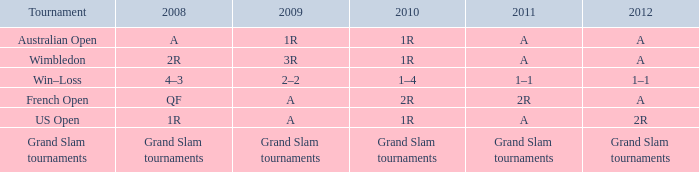Could you parse the entire table as a dict? {'header': ['Tournament', '2008', '2009', '2010', '2011', '2012'], 'rows': [['Australian Open', 'A', '1R', '1R', 'A', 'A'], ['Wimbledon', '2R', '3R', '1R', 'A', 'A'], ['Win–Loss', '4–3', '2–2', '1–4', '1–1', '1–1'], ['French Open', 'QF', 'A', '2R', '2R', 'A'], ['US Open', '1R', 'A', '1R', 'A', '2R'], ['Grand Slam tournaments', 'Grand Slam tournaments', 'Grand Slam tournaments', 'Grand Slam tournaments', 'Grand Slam tournaments', 'Grand Slam tournaments']]} Name the 2011 when 2010 is 2r 2R. 